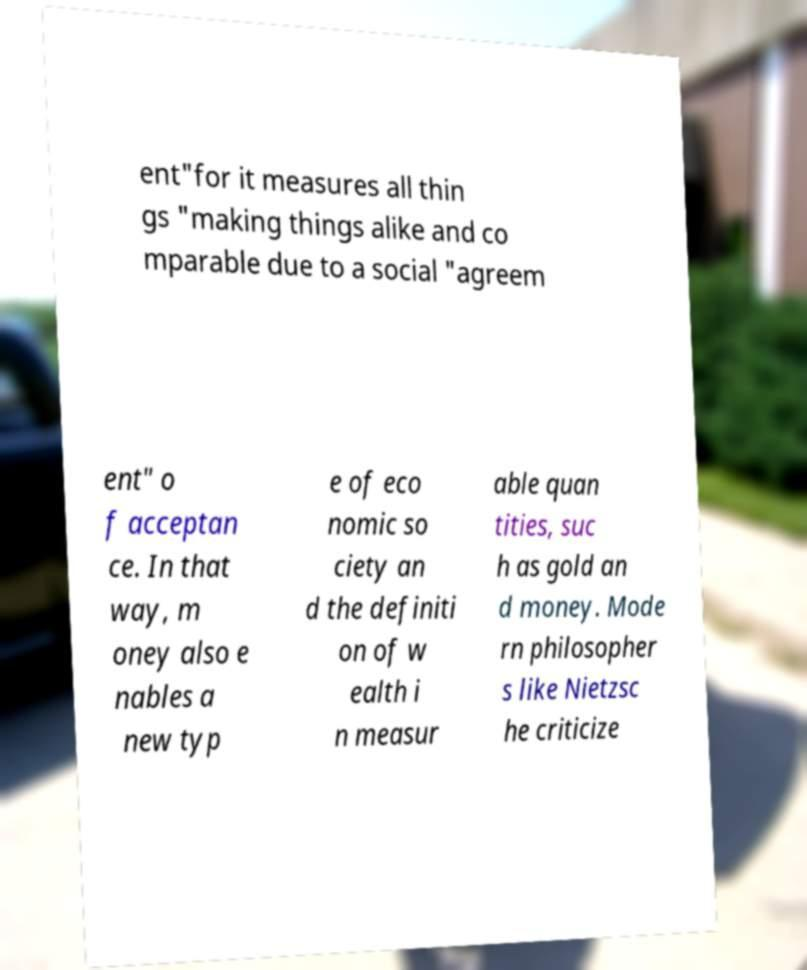There's text embedded in this image that I need extracted. Can you transcribe it verbatim? ent"for it measures all thin gs "making things alike and co mparable due to a social "agreem ent" o f acceptan ce. In that way, m oney also e nables a new typ e of eco nomic so ciety an d the definiti on of w ealth i n measur able quan tities, suc h as gold an d money. Mode rn philosopher s like Nietzsc he criticize 